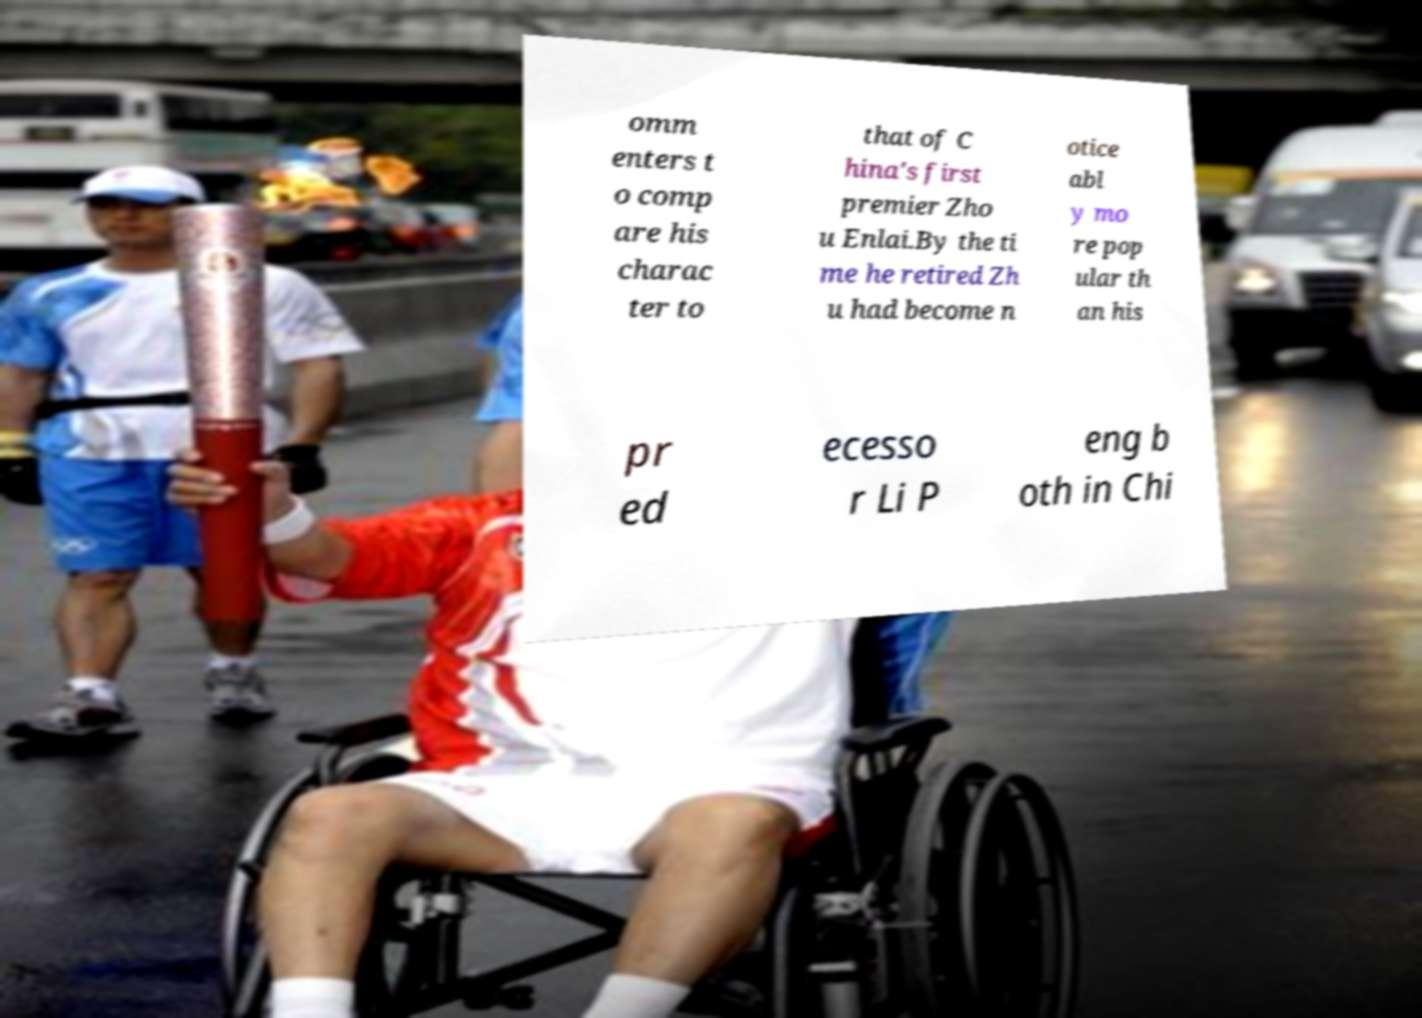For documentation purposes, I need the text within this image transcribed. Could you provide that? omm enters t o comp are his charac ter to that of C hina's first premier Zho u Enlai.By the ti me he retired Zh u had become n otice abl y mo re pop ular th an his pr ed ecesso r Li P eng b oth in Chi 